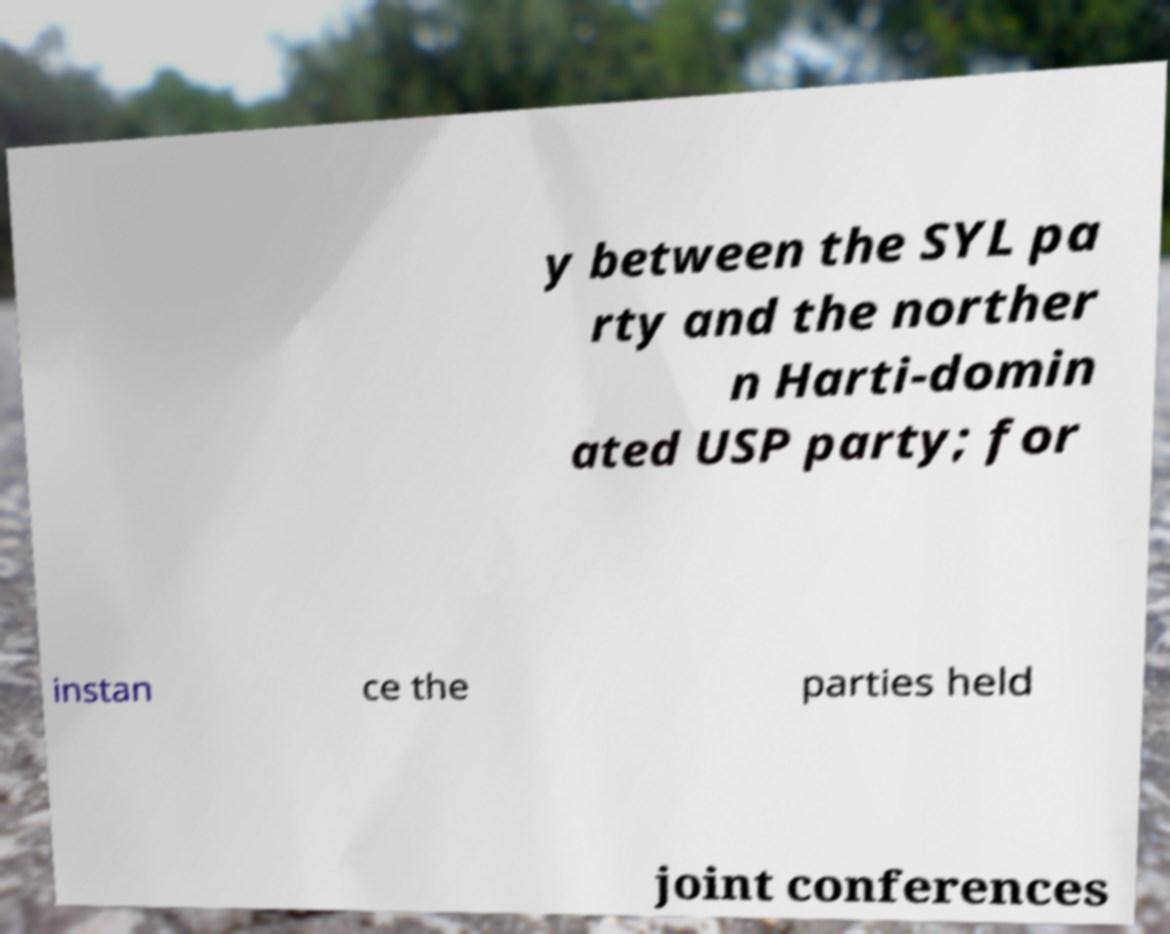Please identify and transcribe the text found in this image. y between the SYL pa rty and the norther n Harti-domin ated USP party; for instan ce the parties held joint conferences 